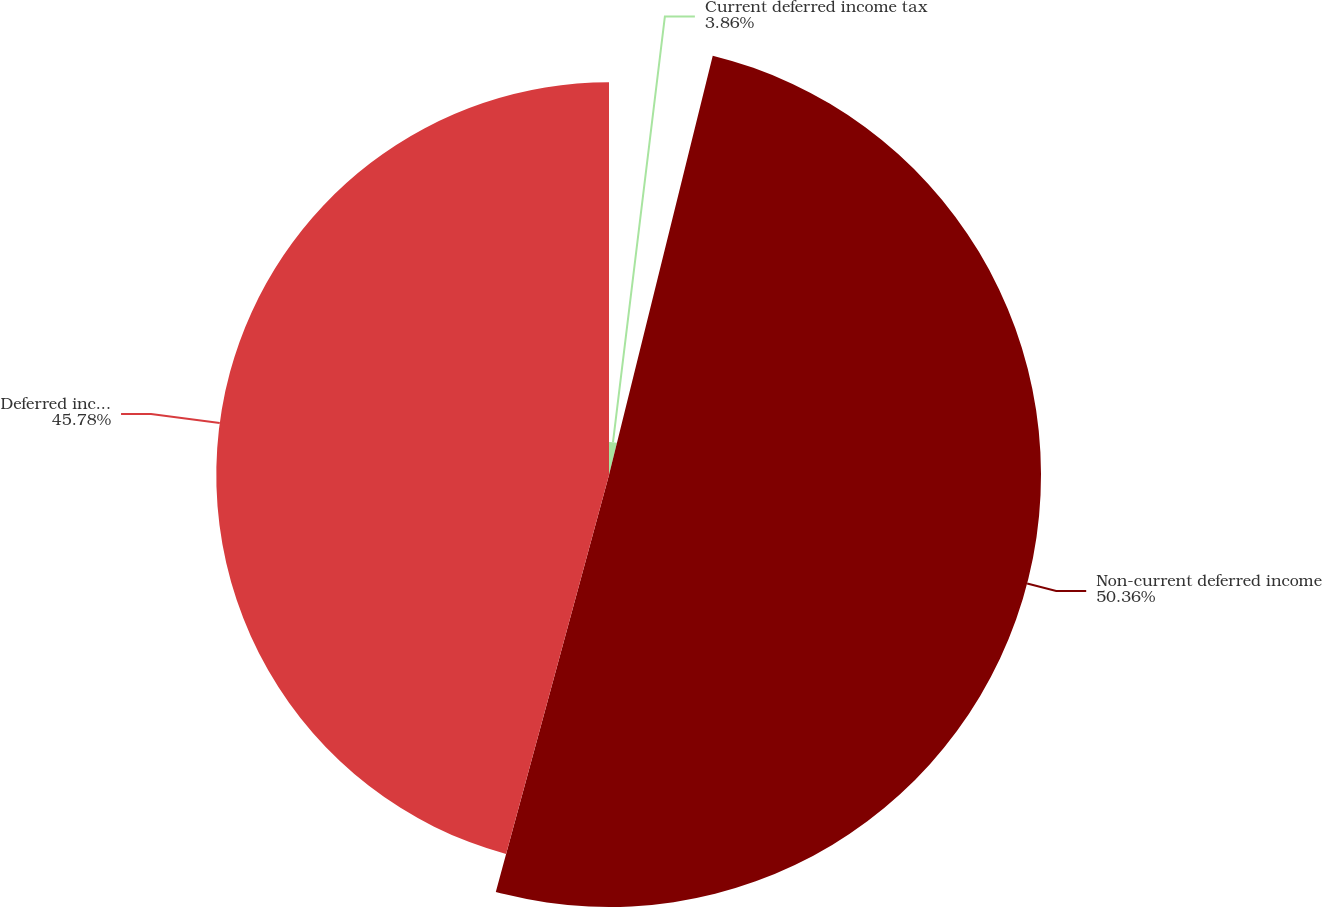<chart> <loc_0><loc_0><loc_500><loc_500><pie_chart><fcel>Current deferred income tax<fcel>Non-current deferred income<fcel>Deferred income tax<nl><fcel>3.86%<fcel>50.36%<fcel>45.78%<nl></chart> 